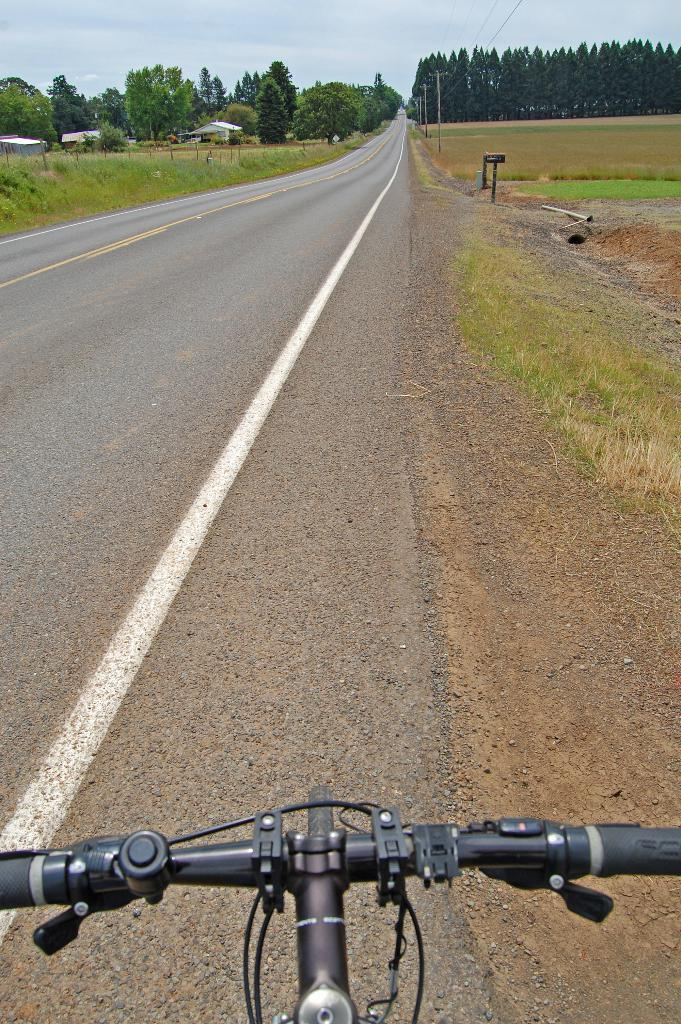What can be seen in the picture that is used to control a cycle? There is a cycle handle in the picture. What type of path is visible in the image? There is a road visible in the image. What type of landscape is present in the image? Grasslands are present in the image. What type of structures can be seen in the image? Houses are visible in the image. What type of vegetation is present in the image? Trees are present in the image. What is the condition of the sky in the background of the image? The sky in the background is cloudy. Where is the key located in the image? There is no key present in the image. What time of day is depicted in the image? The time of day cannot be determined from the image, as there is no specific indication of day or night. 